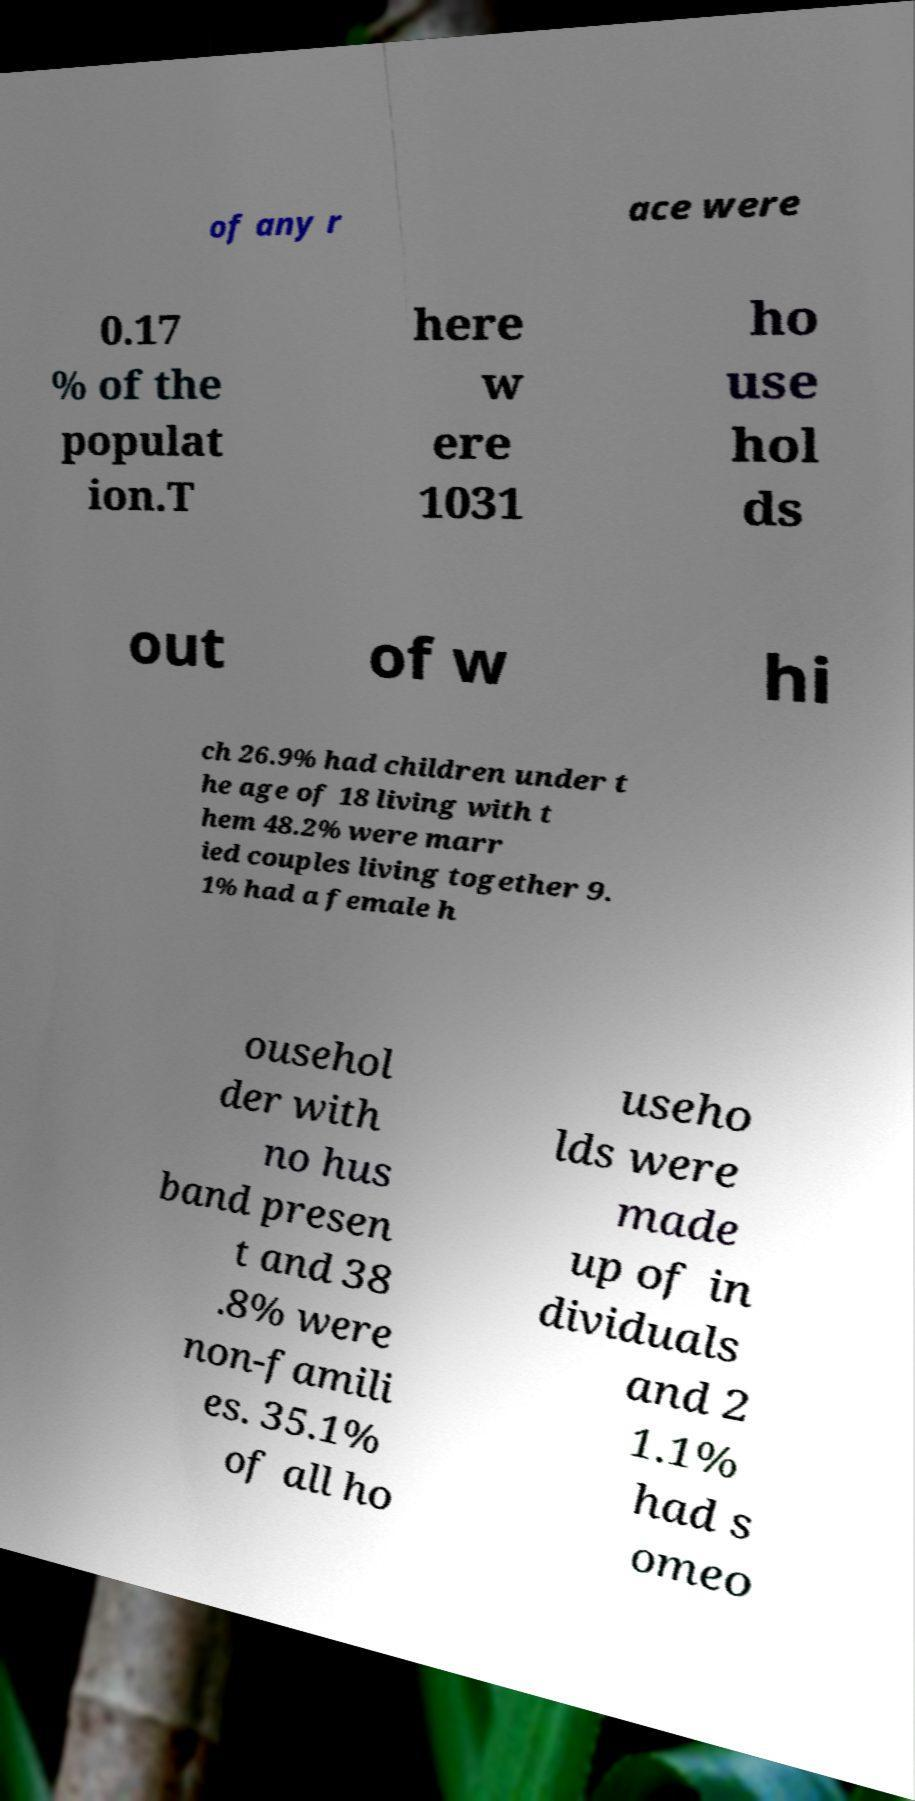Can you read and provide the text displayed in the image?This photo seems to have some interesting text. Can you extract and type it out for me? of any r ace were 0.17 % of the populat ion.T here w ere 1031 ho use hol ds out of w hi ch 26.9% had children under t he age of 18 living with t hem 48.2% were marr ied couples living together 9. 1% had a female h ousehol der with no hus band presen t and 38 .8% were non-famili es. 35.1% of all ho useho lds were made up of in dividuals and 2 1.1% had s omeo 